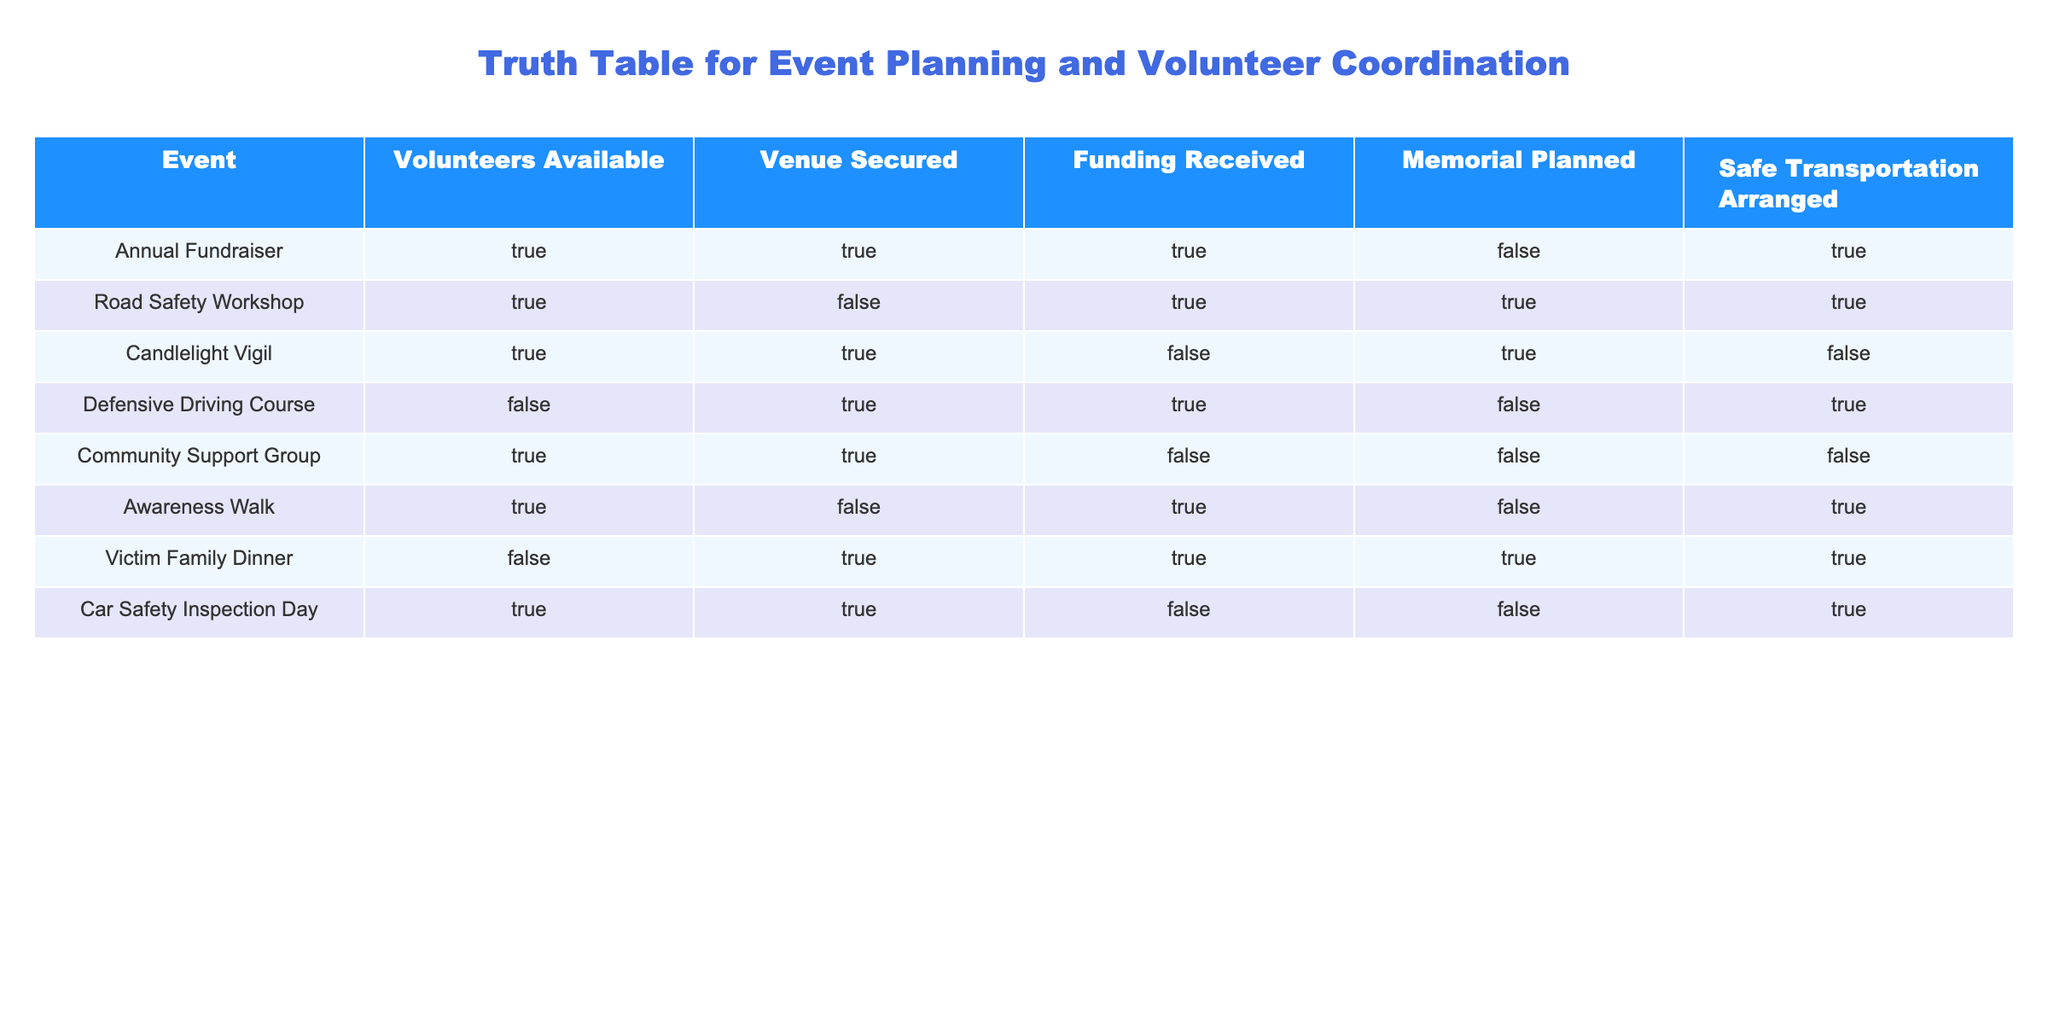What events have funding received and special memorials planned? To answer this, I look for rows where both "Funding Received" and "Memorial Planned" are TRUE. The only event that meets this criteria is the "Road Safety Workshop."
Answer: Road Safety Workshop How many events have safe transportation arranged but don't have a memorial planned? I count the events where "Safe Transportation Arranged" is TRUE and "Memorial Planned" is FALSE. The relevant events are "Annual Fundraiser," "Awareness Walk," and "Car Safety Inspection Day." That gives us a total of 3 events.
Answer: 3 Is there an event planned for which there are volunteers available, funding received, but no memorial planned? I examine the table for rows that show TRUE in "Volunteers Available" and "Funding Received" while being FALSE in "Memorial Planned." The "Annual Fundraiser" and "Awareness Walk" meet these criteria. Therefore, there are two such events.
Answer: Yes What percentage of events secured venues that also arranged safe transportation? First, I identify the events that secured a venue (TRUE under "Venue Secured"): "Annual Fundraiser," "Candlelight Vigil," "Defensive Driving Course," "Community Support Group," "Car Safety Inspection Day." Out of these 5 events, 3 also have safe transportation arranged (Annual Fundraiser, Defensive Driving Course, and Car Safety Inspection Day). The percentage is (3/5) * 100 = 60%.
Answer: 60% Which event has volunteers available but lacks funding received and memorial planned? I filter the events to find where "Volunteers Available" is TRUE and both "Funding Received" and "Memorial Planned" are FALSE. The event "Community Support Group" meets these conditions.
Answer: Community Support Group 